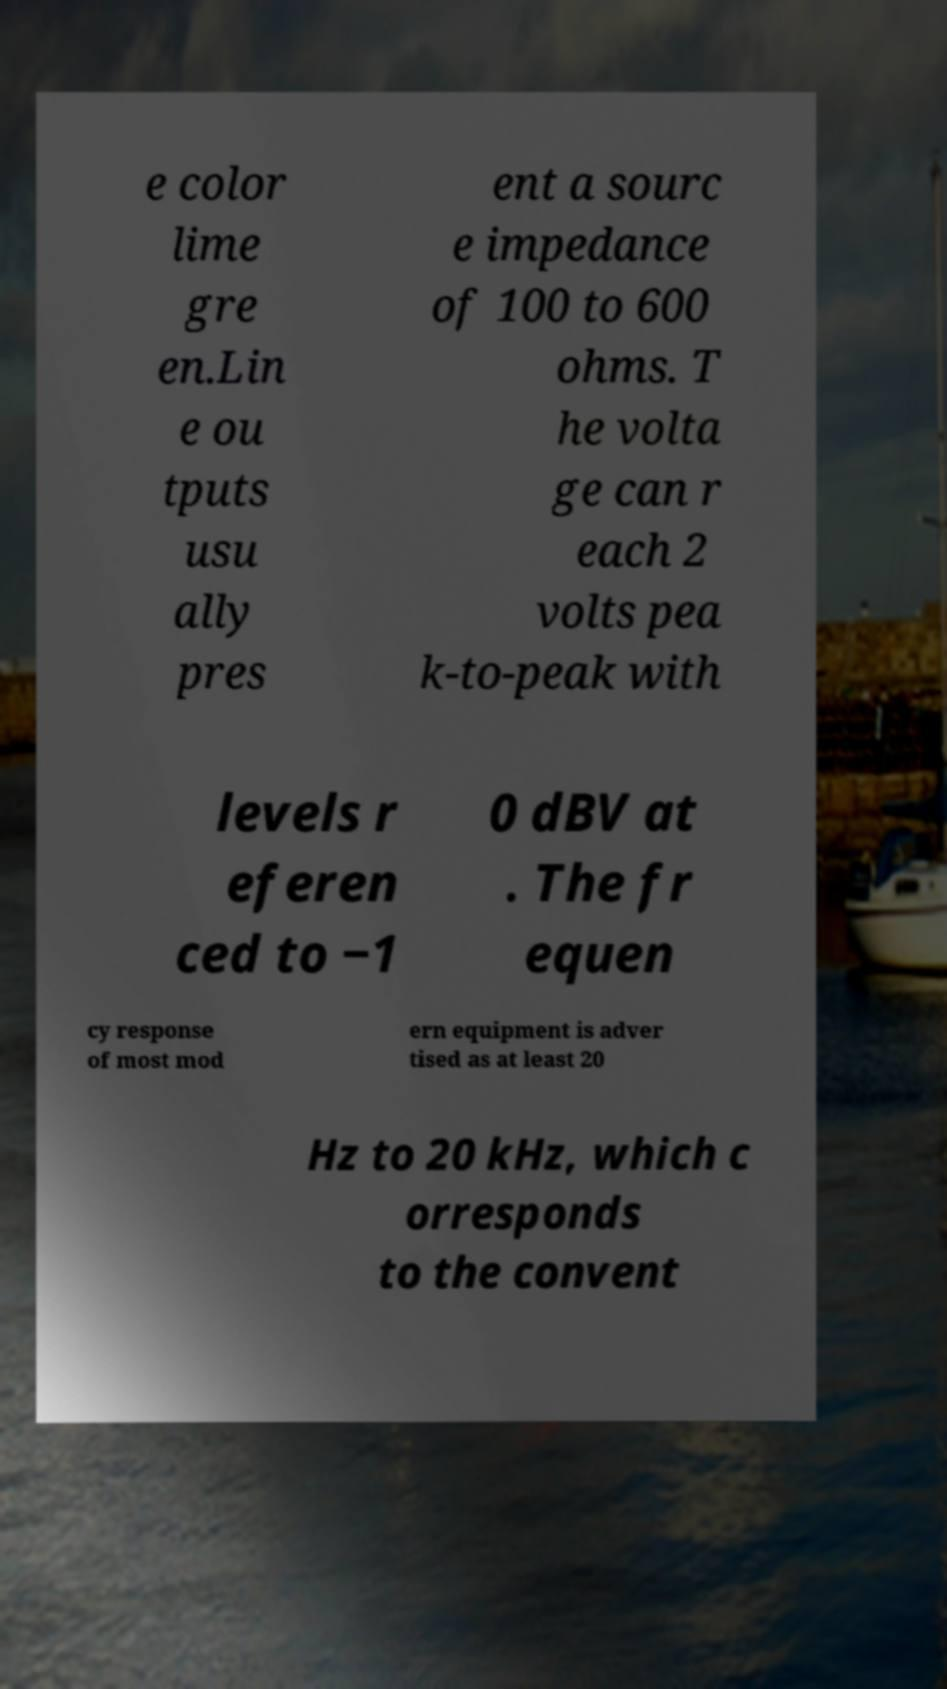What messages or text are displayed in this image? I need them in a readable, typed format. e color lime gre en.Lin e ou tputs usu ally pres ent a sourc e impedance of 100 to 600 ohms. T he volta ge can r each 2 volts pea k-to-peak with levels r eferen ced to −1 0 dBV at . The fr equen cy response of most mod ern equipment is adver tised as at least 20 Hz to 20 kHz, which c orresponds to the convent 